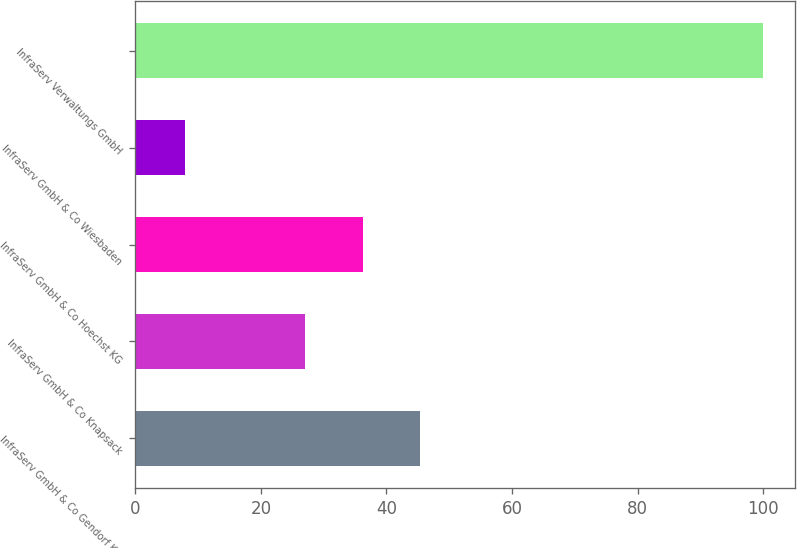Convert chart to OTSL. <chart><loc_0><loc_0><loc_500><loc_500><bar_chart><fcel>InfraServ GmbH & Co Gendorf KG<fcel>InfraServ GmbH & Co Knapsack<fcel>InfraServ GmbH & Co Hoechst KG<fcel>InfraServ GmbH & Co Wiesbaden<fcel>InfraServ Verwaltungs GmbH<nl><fcel>45.4<fcel>27<fcel>36.2<fcel>8<fcel>100<nl></chart> 